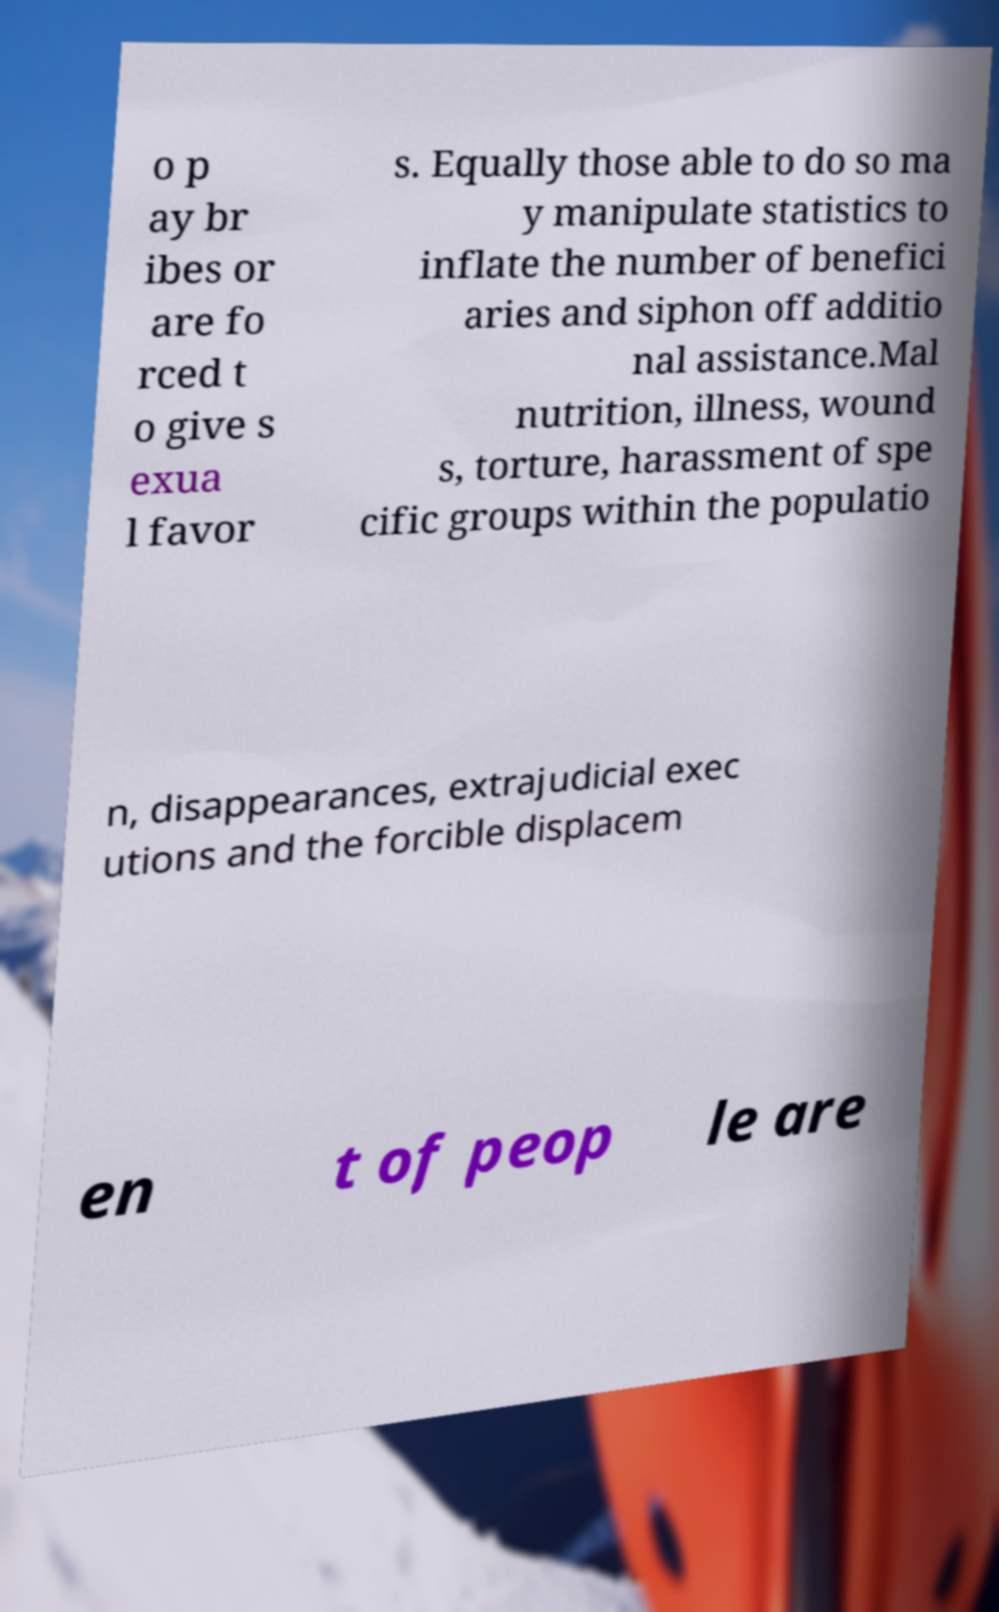For documentation purposes, I need the text within this image transcribed. Could you provide that? o p ay br ibes or are fo rced t o give s exua l favor s. Equally those able to do so ma y manipulate statistics to inflate the number of benefici aries and siphon off additio nal assistance.Mal nutrition, illness, wound s, torture, harassment of spe cific groups within the populatio n, disappearances, extrajudicial exec utions and the forcible displacem en t of peop le are 